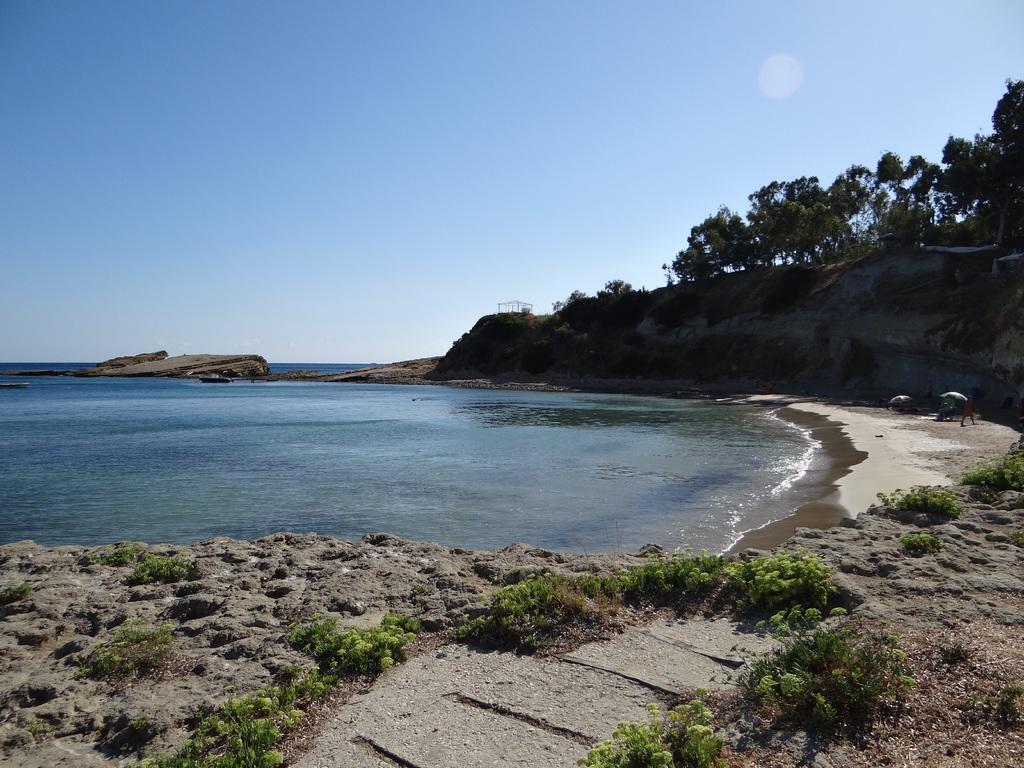How would you summarize this image in a sentence or two? There are plants on the dry land. In the background, there is an ocean, there are trees on a hill and there is a sun in the blue sky. 